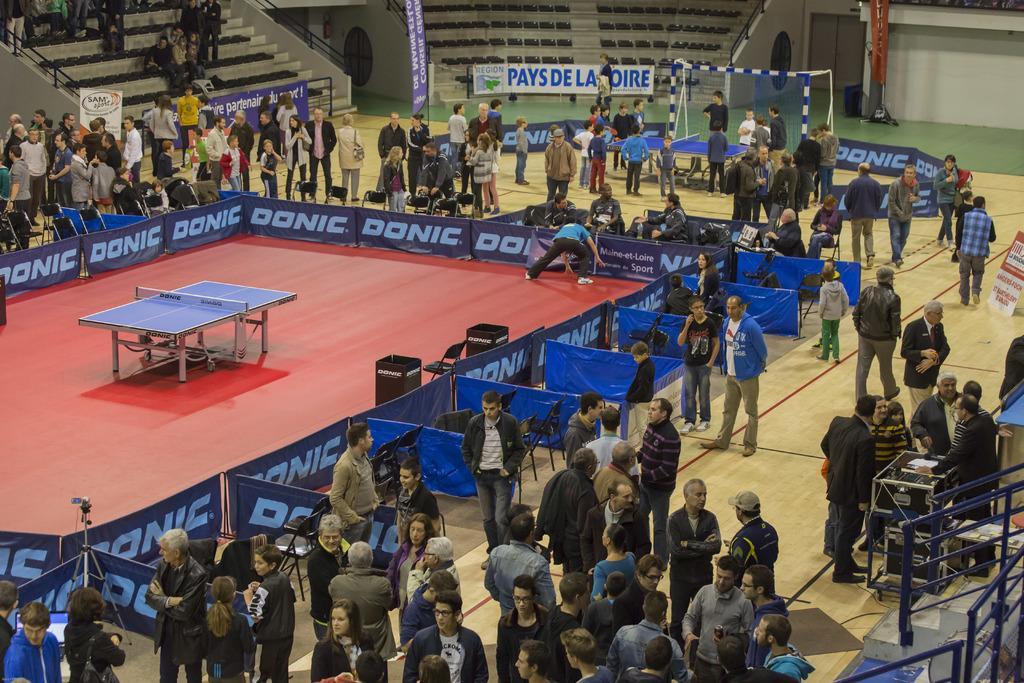Can you describe this image briefly? Group of people standing. We can see a table tennis center of the ground and we can see a banners,hoardings,chairs,floor. 